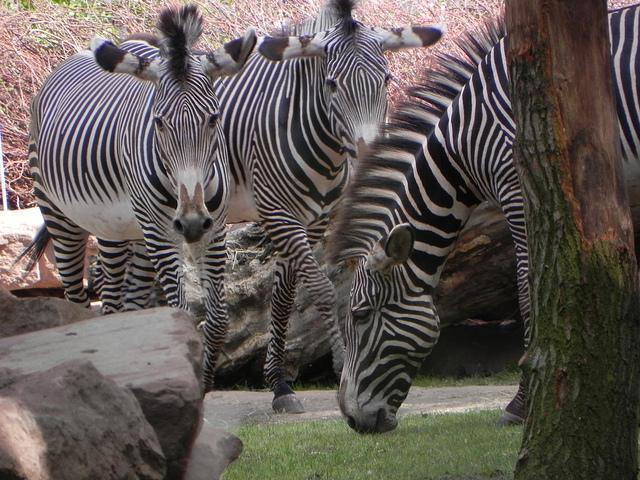What animals are most similar to these?
From the following set of four choices, select the accurate answer to respond to the question.
Options: Bison, horses, wolves, foxes. Horses. 